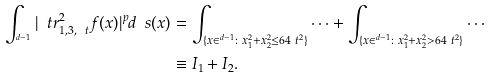<formula> <loc_0><loc_0><loc_500><loc_500>\int _ { ^ { d - 1 } } | \ t r _ { 1 , 3 , \ t } ^ { 2 } f ( x ) | ^ { p } d \ s ( x ) & = \int _ { \{ x \in ^ { d - 1 } \colon x _ { 1 } ^ { 2 } + x _ { 2 } ^ { 2 } \leq 6 4 \ t ^ { 2 } \} } \cdots + \int _ { \{ x \in ^ { d - 1 } \colon x _ { 1 } ^ { 2 } + x _ { 2 } ^ { 2 } > 6 4 \ t ^ { 2 } \} } \cdots \\ & \equiv I _ { 1 } + I _ { 2 } .</formula> 